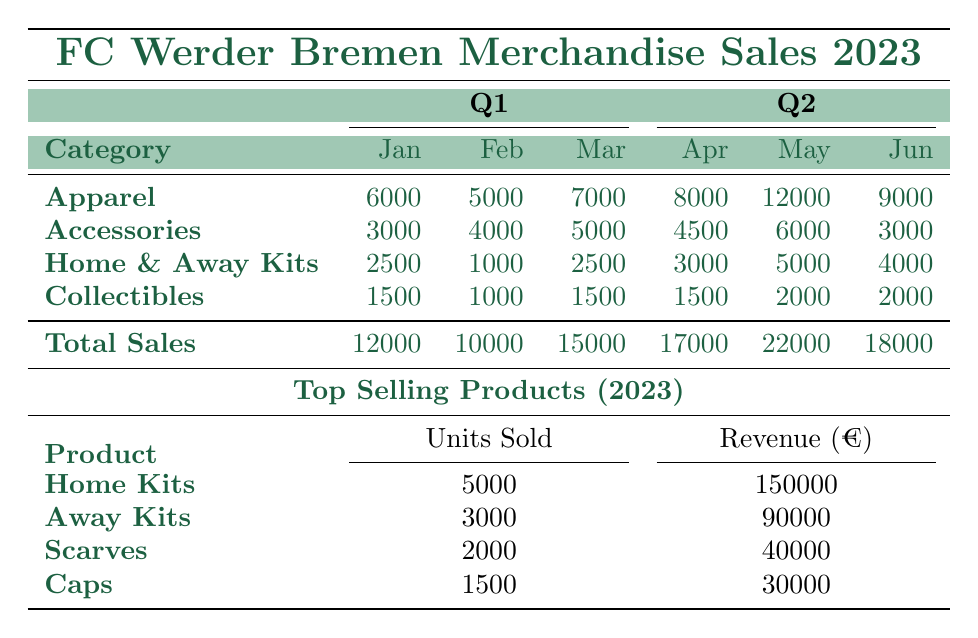What was the total sales for May 2023? The total sales for May is listed under the Q2 column for May. The value is 22000, which is directly stated in the table.
Answer: 22000 Which category had the highest sales in January 2023? Looking at the January column under Q1, Apparel has sales of 6000, Accessories has 3000, Home and Away Kits has 2500, and Collectibles has 1500. Among these, Apparel has the highest sales at 6000.
Answer: Apparel What is the total sales for Q1 2023? To find the total sales for Q1, we need to sum up the total sales for each month: January (12000) + February (10000) + March (15000) = 37000. Therefore, the total sales for Q1 2023 is 37000.
Answer: 37000 Did the sales for Accessories increase from February to March 2023? Analyzing the sales figures for Accessories, February is 4000 and March is 5000. The sales for Accessories did increase from February to March.
Answer: Yes What are the total units sold for the top-selling product in 2023? Referring to the Top Selling Products section, the Home Kits are the top-selling product with total units sold listed as 5000. Thus, the total units sold for the top-selling product is 5000.
Answer: 5000 Which month had the lowest total sales in Q1 2023? The total sales for each month in Q1 are: January (12000), February (10000), and March (15000). February has the lowest total sales at 10000.
Answer: February What was the average sales of all categories for June 2023? June sales for each category are as follows: Apparel (9000), Accessories (3000), Home and Away Kits (4000), Collectibles (2000). The average is calculated as (9000 + 3000 + 4000 + 2000) / 4 = 2250.
Answer: 2250 How much revenue did the Scarves generate? The revenue generated from Scarves is detailed in the Top Selling Products section, where it states the revenue for Scarves is 40000. Thus, the revenue from Scarves is 40000.
Answer: 40000 Did the sales for Home and Away Kits decrease from April to May 2023? In April, Home and Away Kits had sales of 3000, while in May it increased to 5000. Therefore, the sales for Home and Away Kits did not decrease; it actually increased.
Answer: No 